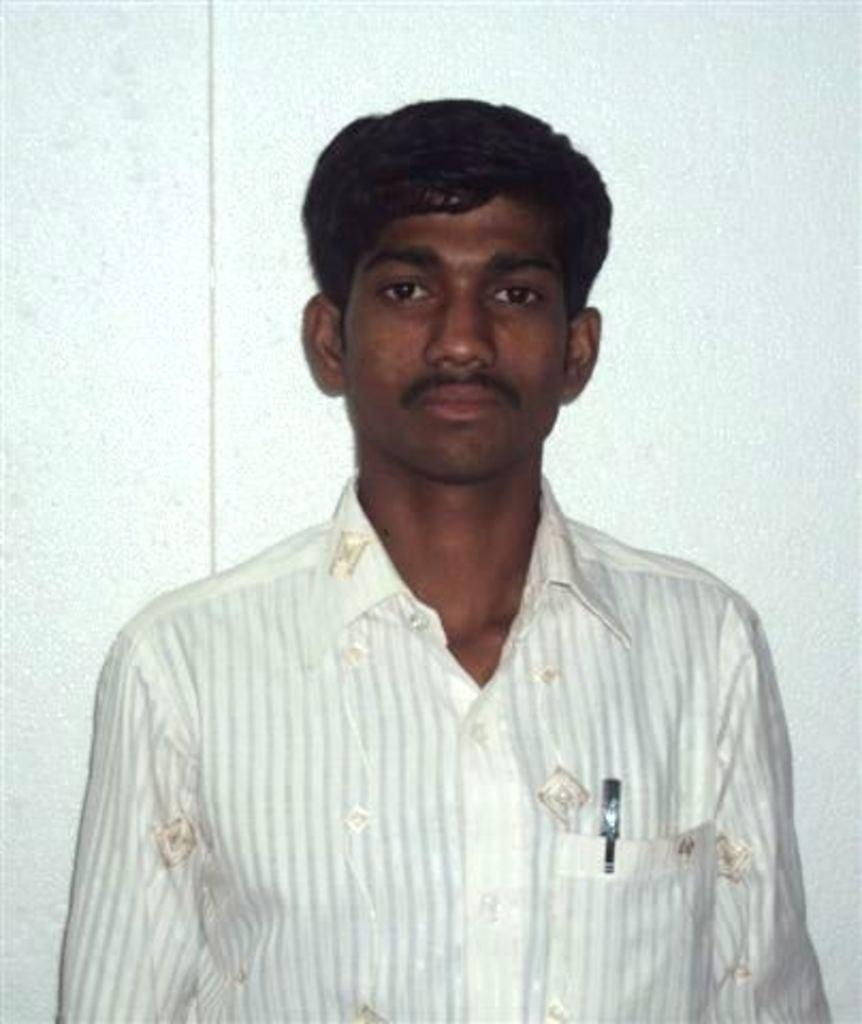What is the main subject of the image? There is a person in the image. What is the person wearing? The person is wearing a white and cream color dress. Can you describe any accessories or items the person is carrying? The person has a pen in their pocket. What is the color of the background in the image? The background of the image is white. What type of drum is the person playing in the image? There is no drum present in the image; the person is simply wearing a white and cream color dress and has a pen in their pocket. Is the person's sister also in the image? The provided facts do not mention the presence of a sister, so we cannot determine if the person's sister is in the image. 